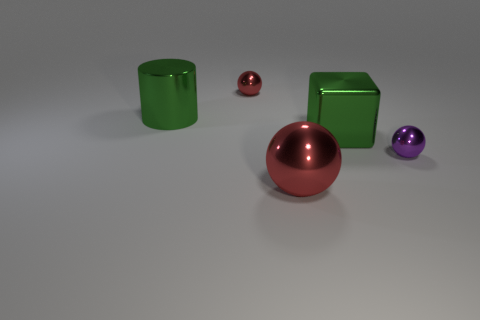Subtract all red spheres. How many spheres are left? 1 Subtract all red blocks. How many red balls are left? 2 Add 3 purple matte cylinders. How many objects exist? 8 Subtract all blocks. How many objects are left? 4 Subtract all blue balls. Subtract all gray cylinders. How many balls are left? 3 Subtract all green shiny cubes. Subtract all large green shiny cubes. How many objects are left? 3 Add 1 red things. How many red things are left? 3 Add 5 large red balls. How many large red balls exist? 6 Subtract 1 green cylinders. How many objects are left? 4 